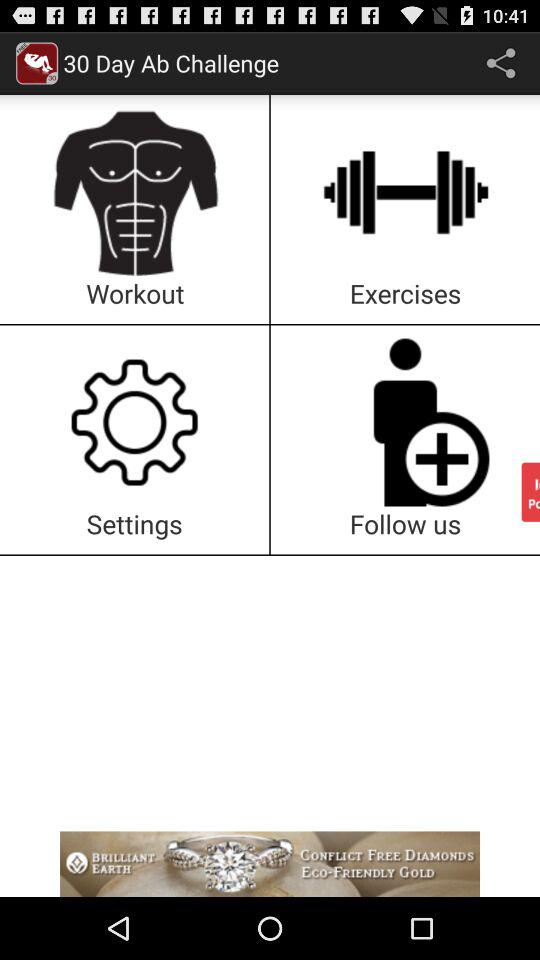What is the app's name? The app's name is "30 Day Ab Challenge". 